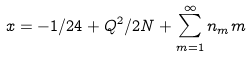Convert formula to latex. <formula><loc_0><loc_0><loc_500><loc_500>x = - 1 / 2 4 + Q ^ { 2 } / 2 N + \sum _ { m = 1 } ^ { \infty } n _ { m } m</formula> 